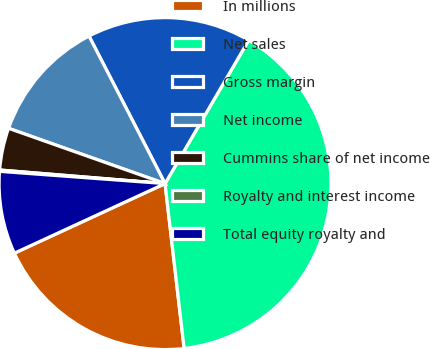<chart> <loc_0><loc_0><loc_500><loc_500><pie_chart><fcel>In millions<fcel>Net sales<fcel>Gross margin<fcel>Net income<fcel>Cummins share of net income<fcel>Royalty and interest income<fcel>Total equity royalty and<nl><fcel>19.95%<fcel>39.76%<fcel>15.98%<fcel>12.02%<fcel>4.1%<fcel>0.13%<fcel>8.06%<nl></chart> 